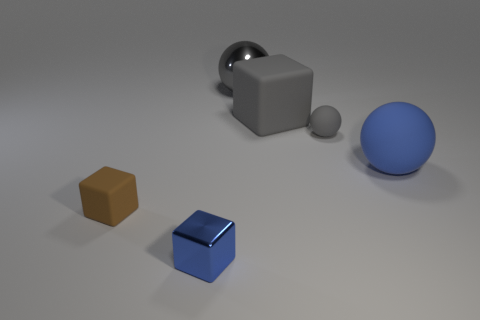Add 1 gray balls. How many objects exist? 7 Subtract all green rubber things. Subtract all gray cubes. How many objects are left? 5 Add 5 blue rubber spheres. How many blue rubber spheres are left? 6 Add 5 brown blocks. How many brown blocks exist? 6 Subtract 0 red cylinders. How many objects are left? 6 